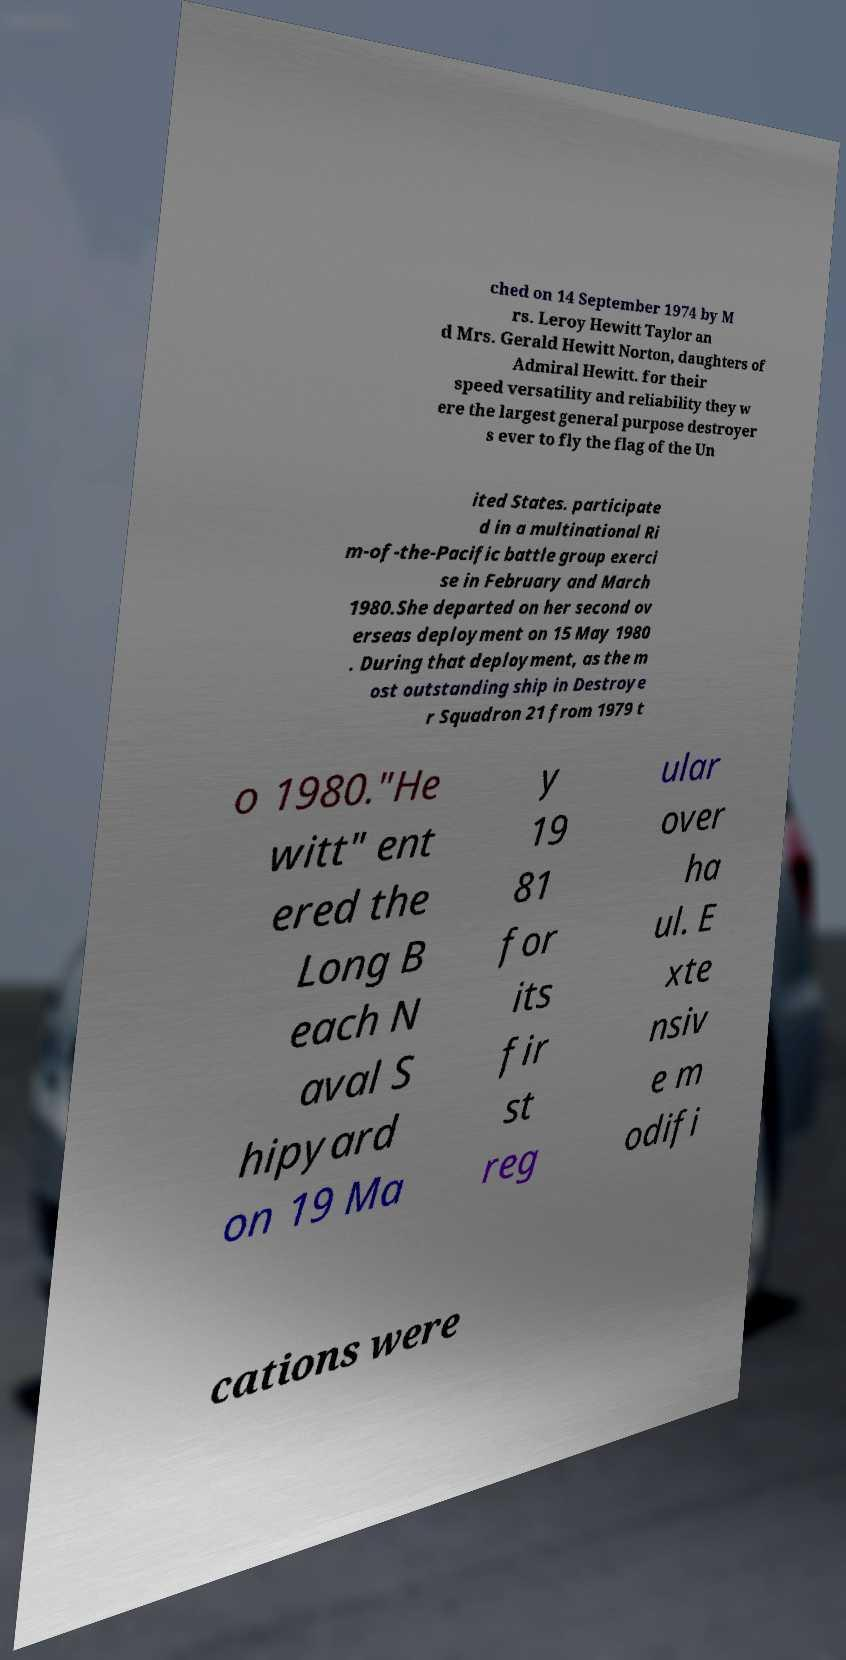Could you assist in decoding the text presented in this image and type it out clearly? ched on 14 September 1974 by M rs. Leroy Hewitt Taylor an d Mrs. Gerald Hewitt Norton, daughters of Admiral Hewitt. for their speed versatility and reliability they w ere the largest general purpose destroyer s ever to fly the flag of the Un ited States. participate d in a multinational Ri m-of-the-Pacific battle group exerci se in February and March 1980.She departed on her second ov erseas deployment on 15 May 1980 . During that deployment, as the m ost outstanding ship in Destroye r Squadron 21 from 1979 t o 1980."He witt" ent ered the Long B each N aval S hipyard on 19 Ma y 19 81 for its fir st reg ular over ha ul. E xte nsiv e m odifi cations were 